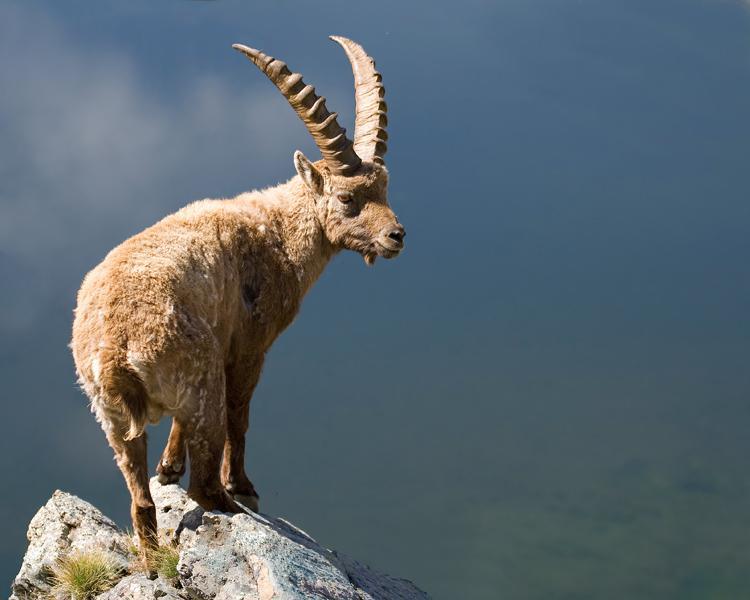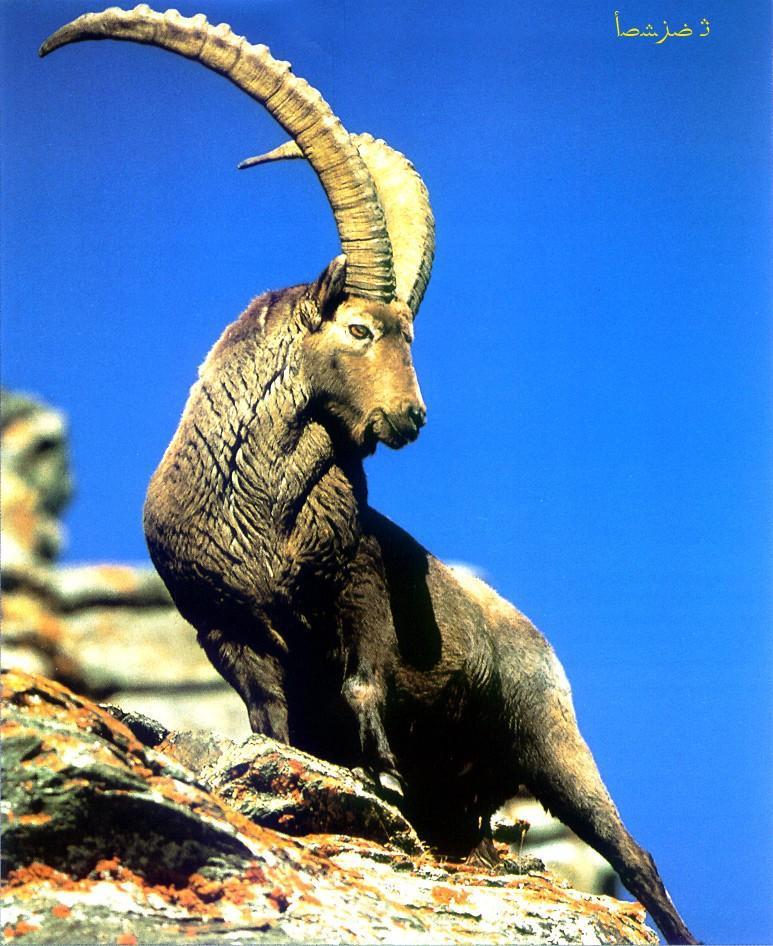The first image is the image on the left, the second image is the image on the right. Assess this claim about the two images: "There are at least two animals in the image on the left.". Correct or not? Answer yes or no. No. 